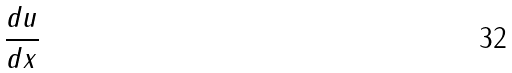Convert formula to latex. <formula><loc_0><loc_0><loc_500><loc_500>\frac { d u } { d x }</formula> 